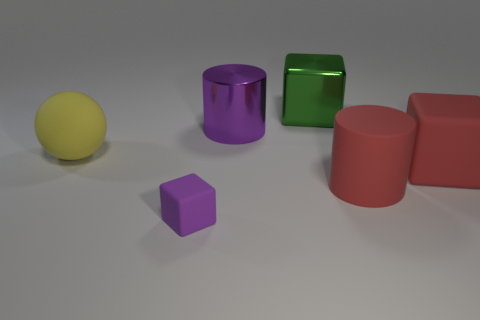Is there any other thing that has the same size as the purple rubber thing?
Your answer should be compact. No. There is a yellow rubber object that is the same size as the green cube; what shape is it?
Offer a very short reply. Sphere. What is the material of the red thing that is behind the cylinder that is in front of the rubber sphere in front of the large shiny cube?
Give a very brief answer. Rubber. Do the sphere and the red cube have the same size?
Keep it short and to the point. Yes. What material is the yellow object?
Make the answer very short. Rubber. There is a cube that is the same color as the large matte cylinder; what is it made of?
Your response must be concise. Rubber. There is a purple object in front of the big yellow ball; does it have the same shape as the green object?
Offer a very short reply. Yes. What number of things are green cubes or small blue rubber objects?
Offer a very short reply. 1. Do the large cylinder that is on the right side of the big green metal thing and the green object have the same material?
Your response must be concise. No. What is the size of the purple rubber object?
Make the answer very short. Small. 